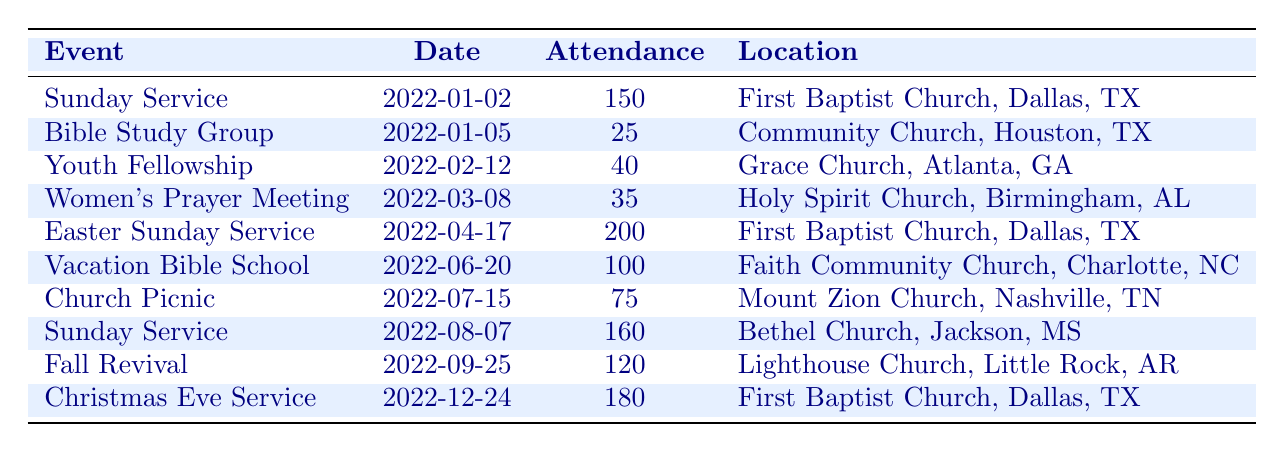What was the attendance at the Easter Sunday Service? The table lists the Easter Sunday Service under "Event" and shows the attendance for that event is recorded as 200.
Answer: 200 Which event had the highest attendance? By comparing the attendance values of all events, the Easter Sunday Service was attended by 200 people, which is the highest attendance recorded in the table.
Answer: Easter Sunday Service How many events had an attendance of 100 or more? The events with attendance of 100 or more are: Easter Sunday Service (200), Christmas Eve Service (180), Sunday Service (160), and Vacation Bible School (100). That totals 4 events.
Answer: 4 What is the average attendance for all church events listed in the table? First, sum the attendance numbers: 150 + 25 + 40 + 35 + 200 + 100 + 75 + 160 + 120 + 180 = 1,080. There are 10 events in total, so the average is 1,080 divided by 10, which equals 108.
Answer: 108 Was the Women's Prayer Meeting the least attended event? Checking the attendance values, the Women's Prayer Meeting had an attendance of 35, while the Bible Study Group had an attendance of 25, which is lower. Therefore, the Women's Prayer Meeting was not the least attended event.
Answer: No How many events took place at the First Baptist Church? The First Baptist Church hosted three events: Sunday Service on January 2, Easter Sunday Service on April 17, and Christmas Eve Service on December 24.
Answer: 3 Did the Church Picnic have a higher attendance than the Youth Fellowship? The Church Picnic had an attendance of 75, while the Youth Fellowship had an attendance of 40. Since 75 is greater than 40, the Church Picnic did have higher attendance.
Answer: Yes Which month had the highest attendance at events? The highest single event attendance occurred in April with the Easter Sunday Service (200). Other months had lower values, confirming April as the highest month based on that event.
Answer: April 